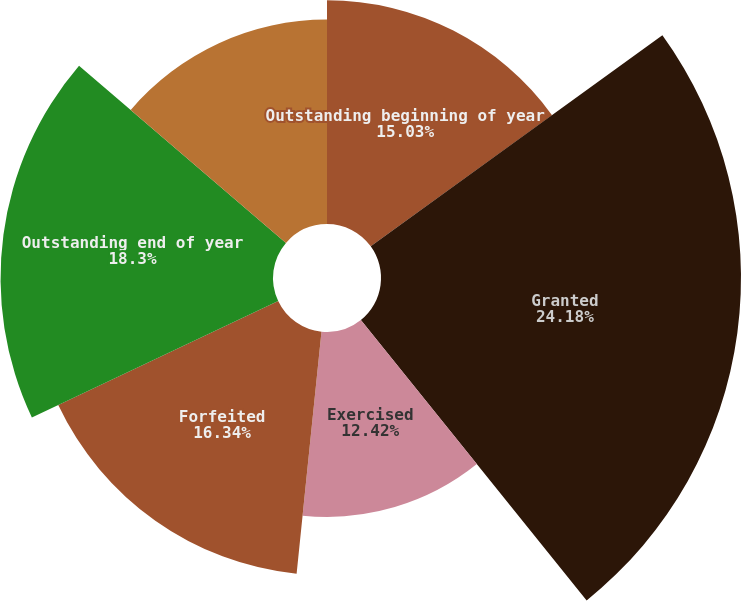Convert chart. <chart><loc_0><loc_0><loc_500><loc_500><pie_chart><fcel>Outstanding beginning of year<fcel>Granted<fcel>Exercised<fcel>Forfeited<fcel>Outstanding end of year<fcel>Options exercisable at<nl><fcel>15.03%<fcel>24.18%<fcel>12.42%<fcel>16.34%<fcel>18.3%<fcel>13.73%<nl></chart> 